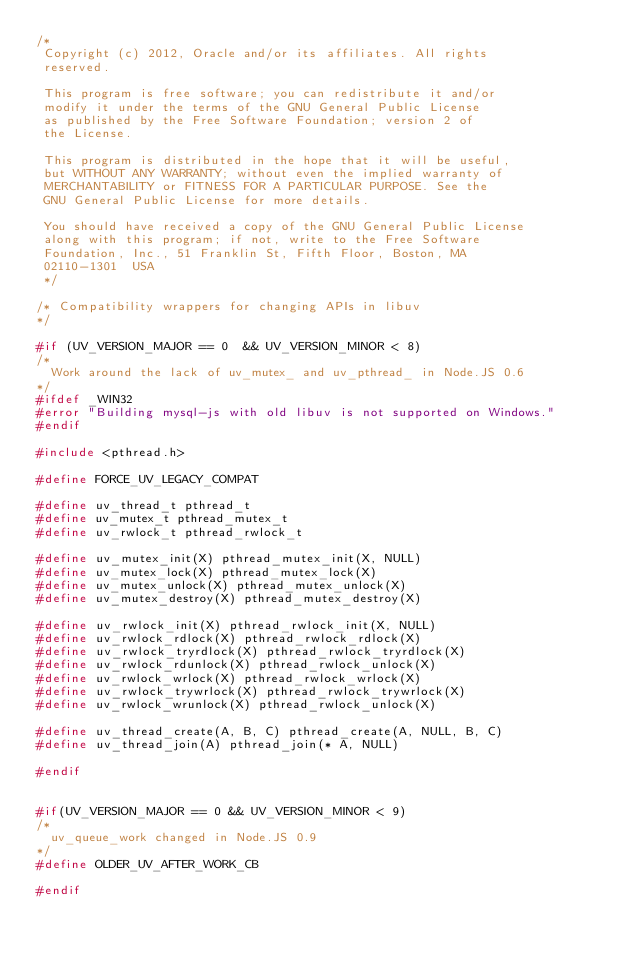Convert code to text. <code><loc_0><loc_0><loc_500><loc_500><_C_>/*
 Copyright (c) 2012, Oracle and/or its affiliates. All rights
 reserved.
 
 This program is free software; you can redistribute it and/or
 modify it under the terms of the GNU General Public License
 as published by the Free Software Foundation; version 2 of
 the License.
 
 This program is distributed in the hope that it will be useful,
 but WITHOUT ANY WARRANTY; without even the implied warranty of
 MERCHANTABILITY or FITNESS FOR A PARTICULAR PURPOSE. See the
 GNU General Public License for more details.
 
 You should have received a copy of the GNU General Public License
 along with this program; if not, write to the Free Software
 Foundation, Inc., 51 Franklin St, Fifth Floor, Boston, MA
 02110-1301  USA
 */

/* Compatibility wrappers for changing APIs in libuv 
*/

#if (UV_VERSION_MAJOR == 0  && UV_VERSION_MINOR < 8) 
/*
  Work around the lack of uv_mutex_ and uv_pthread_ in Node.JS 0.6
*/
#ifdef _WIN32
#error "Building mysql-js with old libuv is not supported on Windows."
#endif

#include <pthread.h>

#define FORCE_UV_LEGACY_COMPAT 

#define uv_thread_t pthread_t
#define uv_mutex_t pthread_mutex_t
#define uv_rwlock_t pthread_rwlock_t

#define uv_mutex_init(X) pthread_mutex_init(X, NULL)
#define uv_mutex_lock(X) pthread_mutex_lock(X)
#define uv_mutex_unlock(X) pthread_mutex_unlock(X)
#define uv_mutex_destroy(X) pthread_mutex_destroy(X) 

#define uv_rwlock_init(X) pthread_rwlock_init(X, NULL)
#define uv_rwlock_rdlock(X) pthread_rwlock_rdlock(X)
#define uv_rwlock_tryrdlock(X) pthread_rwlock_tryrdlock(X)
#define uv_rwlock_rdunlock(X) pthread_rwlock_unlock(X)
#define uv_rwlock_wrlock(X) pthread_rwlock_wrlock(X)
#define uv_rwlock_trywrlock(X) pthread_rwlock_trywrlock(X)
#define uv_rwlock_wrunlock(X) pthread_rwlock_unlock(X)

#define uv_thread_create(A, B, C) pthread_create(A, NULL, B, C)
#define uv_thread_join(A) pthread_join(* A, NULL)

#endif


#if(UV_VERSION_MAJOR == 0 && UV_VERSION_MINOR < 9)
/* 
  uv_queue_work changed in Node.JS 0.9
*/
#define OLDER_UV_AFTER_WORK_CB

#endif

</code> 